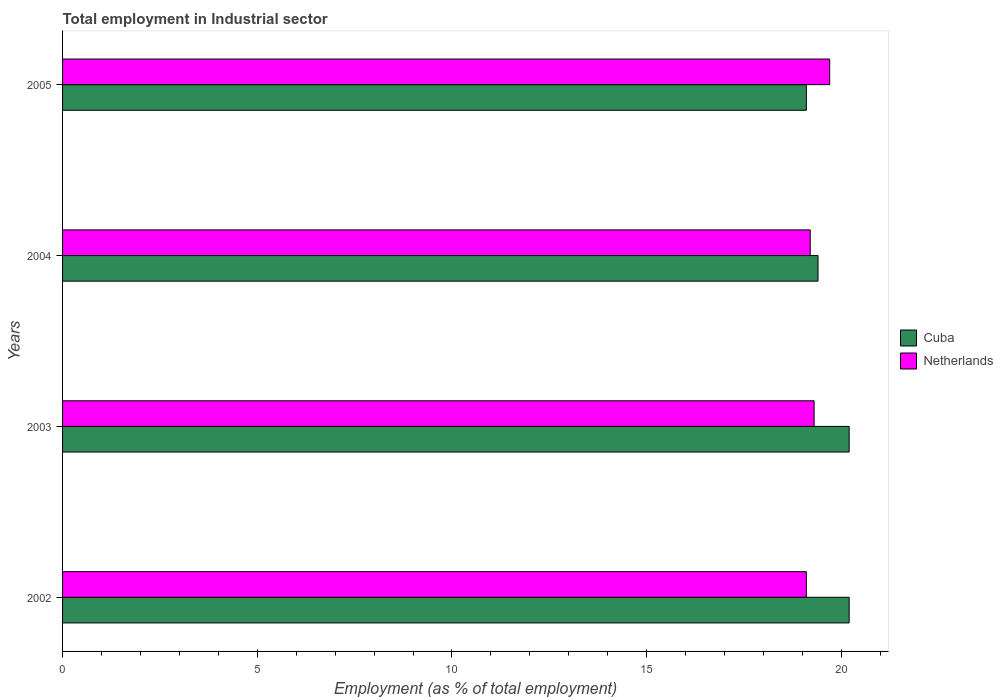How many different coloured bars are there?
Offer a very short reply. 2. Are the number of bars on each tick of the Y-axis equal?
Your response must be concise. Yes. How many bars are there on the 4th tick from the top?
Give a very brief answer. 2. How many bars are there on the 1st tick from the bottom?
Provide a short and direct response. 2. In how many cases, is the number of bars for a given year not equal to the number of legend labels?
Give a very brief answer. 0. What is the employment in industrial sector in Netherlands in 2002?
Your answer should be very brief. 19.1. Across all years, what is the maximum employment in industrial sector in Netherlands?
Your answer should be very brief. 19.7. Across all years, what is the minimum employment in industrial sector in Netherlands?
Ensure brevity in your answer.  19.1. In which year was the employment in industrial sector in Netherlands maximum?
Give a very brief answer. 2005. In which year was the employment in industrial sector in Netherlands minimum?
Give a very brief answer. 2002. What is the total employment in industrial sector in Cuba in the graph?
Give a very brief answer. 78.9. What is the difference between the employment in industrial sector in Netherlands in 2005 and the employment in industrial sector in Cuba in 2002?
Give a very brief answer. -0.5. What is the average employment in industrial sector in Cuba per year?
Provide a short and direct response. 19.73. In the year 2005, what is the difference between the employment in industrial sector in Netherlands and employment in industrial sector in Cuba?
Offer a very short reply. 0.6. In how many years, is the employment in industrial sector in Netherlands greater than 19 %?
Your response must be concise. 4. What is the ratio of the employment in industrial sector in Netherlands in 2003 to that in 2005?
Keep it short and to the point. 0.98. Is the employment in industrial sector in Netherlands in 2003 less than that in 2004?
Make the answer very short. No. What is the difference between the highest and the lowest employment in industrial sector in Cuba?
Offer a very short reply. 1.1. Is the sum of the employment in industrial sector in Cuba in 2002 and 2003 greater than the maximum employment in industrial sector in Netherlands across all years?
Your answer should be very brief. Yes. What does the 2nd bar from the top in 2003 represents?
Give a very brief answer. Cuba. What does the 1st bar from the bottom in 2002 represents?
Your answer should be compact. Cuba. Does the graph contain any zero values?
Make the answer very short. No. Does the graph contain grids?
Offer a terse response. No. Where does the legend appear in the graph?
Your answer should be compact. Center right. How many legend labels are there?
Provide a succinct answer. 2. How are the legend labels stacked?
Offer a very short reply. Vertical. What is the title of the graph?
Keep it short and to the point. Total employment in Industrial sector. Does "Honduras" appear as one of the legend labels in the graph?
Provide a short and direct response. No. What is the label or title of the X-axis?
Ensure brevity in your answer.  Employment (as % of total employment). What is the label or title of the Y-axis?
Offer a terse response. Years. What is the Employment (as % of total employment) of Cuba in 2002?
Your answer should be very brief. 20.2. What is the Employment (as % of total employment) of Netherlands in 2002?
Ensure brevity in your answer.  19.1. What is the Employment (as % of total employment) in Cuba in 2003?
Provide a succinct answer. 20.2. What is the Employment (as % of total employment) in Netherlands in 2003?
Offer a terse response. 19.3. What is the Employment (as % of total employment) of Cuba in 2004?
Your response must be concise. 19.4. What is the Employment (as % of total employment) in Netherlands in 2004?
Your response must be concise. 19.2. What is the Employment (as % of total employment) of Cuba in 2005?
Ensure brevity in your answer.  19.1. What is the Employment (as % of total employment) in Netherlands in 2005?
Provide a short and direct response. 19.7. Across all years, what is the maximum Employment (as % of total employment) in Cuba?
Your answer should be very brief. 20.2. Across all years, what is the maximum Employment (as % of total employment) in Netherlands?
Keep it short and to the point. 19.7. Across all years, what is the minimum Employment (as % of total employment) in Cuba?
Give a very brief answer. 19.1. Across all years, what is the minimum Employment (as % of total employment) in Netherlands?
Your response must be concise. 19.1. What is the total Employment (as % of total employment) of Cuba in the graph?
Your answer should be compact. 78.9. What is the total Employment (as % of total employment) in Netherlands in the graph?
Offer a terse response. 77.3. What is the difference between the Employment (as % of total employment) in Netherlands in 2002 and that in 2003?
Ensure brevity in your answer.  -0.2. What is the difference between the Employment (as % of total employment) in Cuba in 2002 and that in 2004?
Offer a terse response. 0.8. What is the difference between the Employment (as % of total employment) in Cuba in 2003 and that in 2004?
Keep it short and to the point. 0.8. What is the difference between the Employment (as % of total employment) in Netherlands in 2003 and that in 2005?
Provide a succinct answer. -0.4. What is the difference between the Employment (as % of total employment) of Cuba in 2004 and that in 2005?
Provide a short and direct response. 0.3. What is the difference between the Employment (as % of total employment) of Netherlands in 2004 and that in 2005?
Give a very brief answer. -0.5. What is the difference between the Employment (as % of total employment) of Cuba in 2002 and the Employment (as % of total employment) of Netherlands in 2003?
Offer a terse response. 0.9. What is the difference between the Employment (as % of total employment) in Cuba in 2002 and the Employment (as % of total employment) in Netherlands in 2004?
Keep it short and to the point. 1. What is the difference between the Employment (as % of total employment) of Cuba in 2002 and the Employment (as % of total employment) of Netherlands in 2005?
Give a very brief answer. 0.5. What is the difference between the Employment (as % of total employment) in Cuba in 2003 and the Employment (as % of total employment) in Netherlands in 2004?
Provide a short and direct response. 1. What is the difference between the Employment (as % of total employment) in Cuba in 2004 and the Employment (as % of total employment) in Netherlands in 2005?
Your answer should be very brief. -0.3. What is the average Employment (as % of total employment) of Cuba per year?
Offer a terse response. 19.73. What is the average Employment (as % of total employment) in Netherlands per year?
Offer a very short reply. 19.32. In the year 2003, what is the difference between the Employment (as % of total employment) of Cuba and Employment (as % of total employment) of Netherlands?
Provide a succinct answer. 0.9. In the year 2005, what is the difference between the Employment (as % of total employment) of Cuba and Employment (as % of total employment) of Netherlands?
Offer a terse response. -0.6. What is the ratio of the Employment (as % of total employment) in Cuba in 2002 to that in 2003?
Your answer should be very brief. 1. What is the ratio of the Employment (as % of total employment) in Netherlands in 2002 to that in 2003?
Ensure brevity in your answer.  0.99. What is the ratio of the Employment (as % of total employment) in Cuba in 2002 to that in 2004?
Ensure brevity in your answer.  1.04. What is the ratio of the Employment (as % of total employment) of Netherlands in 2002 to that in 2004?
Offer a terse response. 0.99. What is the ratio of the Employment (as % of total employment) of Cuba in 2002 to that in 2005?
Your answer should be compact. 1.06. What is the ratio of the Employment (as % of total employment) of Netherlands in 2002 to that in 2005?
Offer a very short reply. 0.97. What is the ratio of the Employment (as % of total employment) of Cuba in 2003 to that in 2004?
Offer a very short reply. 1.04. What is the ratio of the Employment (as % of total employment) in Netherlands in 2003 to that in 2004?
Give a very brief answer. 1.01. What is the ratio of the Employment (as % of total employment) in Cuba in 2003 to that in 2005?
Provide a succinct answer. 1.06. What is the ratio of the Employment (as % of total employment) of Netherlands in 2003 to that in 2005?
Provide a short and direct response. 0.98. What is the ratio of the Employment (as % of total employment) in Cuba in 2004 to that in 2005?
Ensure brevity in your answer.  1.02. What is the ratio of the Employment (as % of total employment) of Netherlands in 2004 to that in 2005?
Provide a succinct answer. 0.97. 